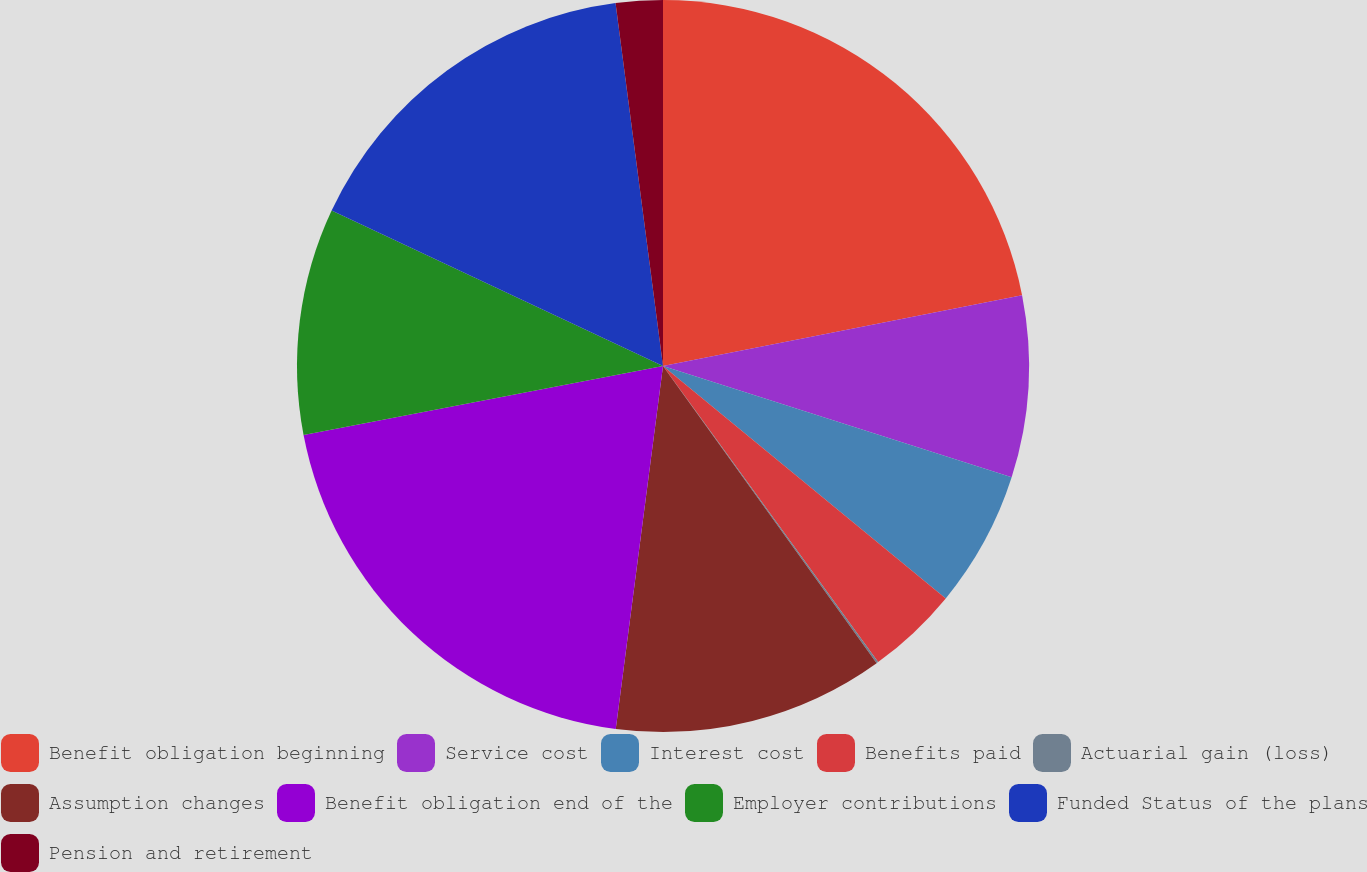<chart> <loc_0><loc_0><loc_500><loc_500><pie_chart><fcel>Benefit obligation beginning<fcel>Service cost<fcel>Interest cost<fcel>Benefits paid<fcel>Actuarial gain (loss)<fcel>Assumption changes<fcel>Benefit obligation end of the<fcel>Employer contributions<fcel>Funded Status of the plans<fcel>Pension and retirement<nl><fcel>21.9%<fcel>8.02%<fcel>6.03%<fcel>4.05%<fcel>0.08%<fcel>11.98%<fcel>19.92%<fcel>10.0%<fcel>15.95%<fcel>2.07%<nl></chart> 